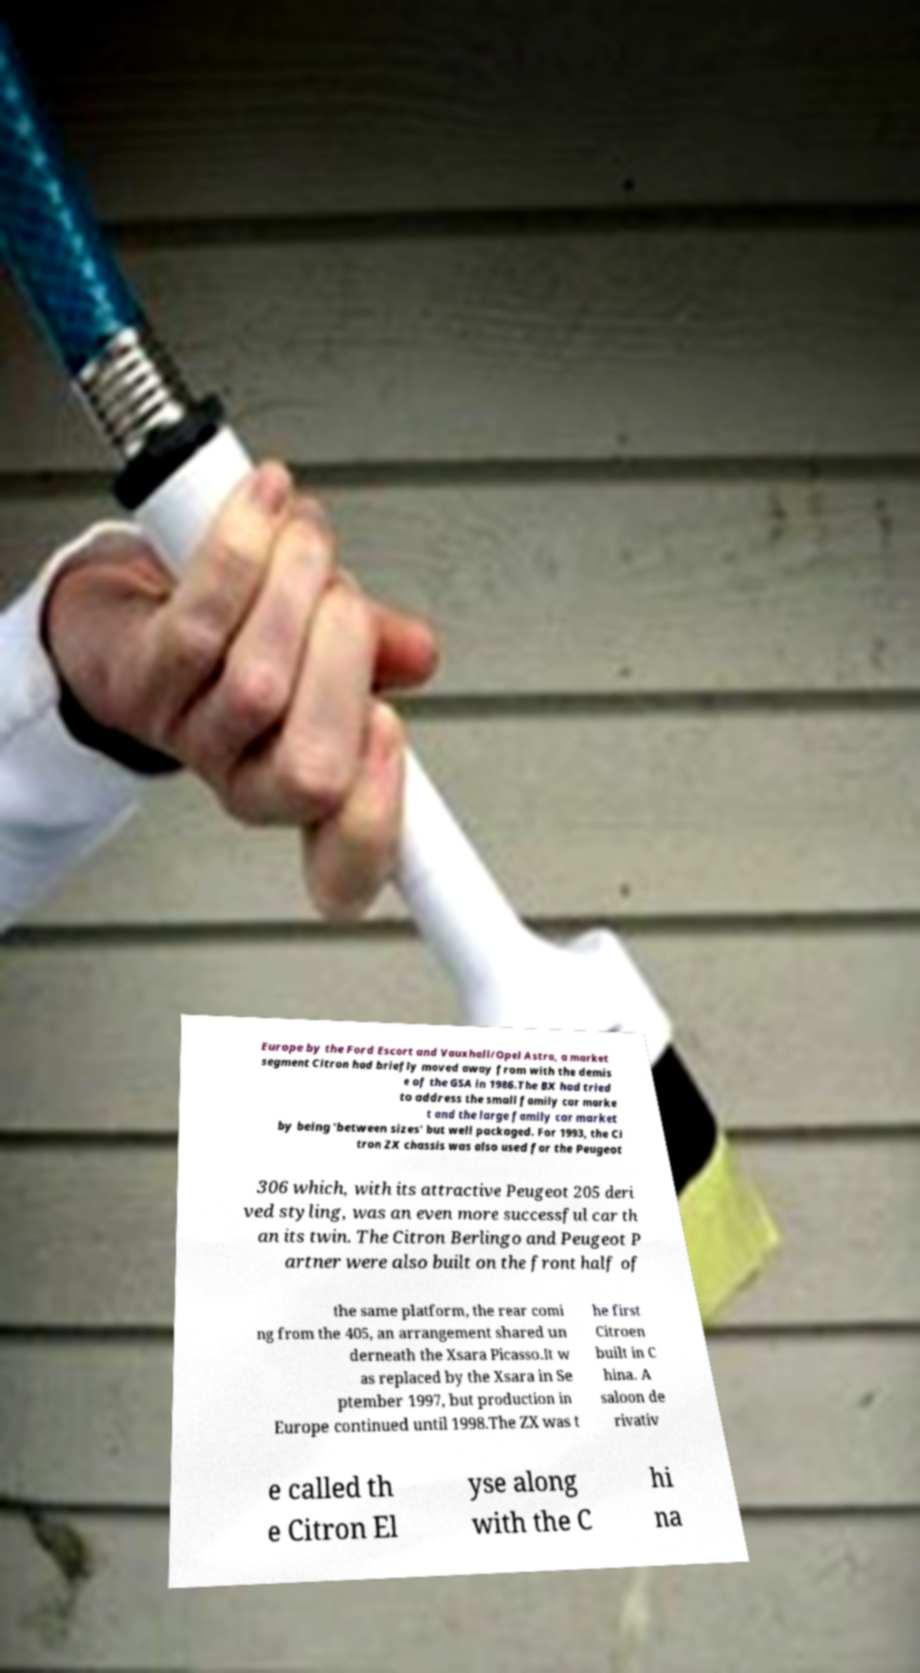I need the written content from this picture converted into text. Can you do that? Europe by the Ford Escort and Vauxhall/Opel Astra, a market segment Citron had briefly moved away from with the demis e of the GSA in 1986.The BX had tried to address the small family car marke t and the large family car market by being 'between sizes' but well packaged. For 1993, the Ci tron ZX chassis was also used for the Peugeot 306 which, with its attractive Peugeot 205 deri ved styling, was an even more successful car th an its twin. The Citron Berlingo and Peugeot P artner were also built on the front half of the same platform, the rear comi ng from the 405, an arrangement shared un derneath the Xsara Picasso.It w as replaced by the Xsara in Se ptember 1997, but production in Europe continued until 1998.The ZX was t he first Citroen built in C hina. A saloon de rivativ e called th e Citron El yse along with the C hi na 